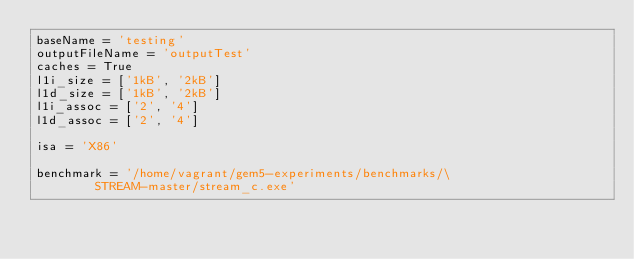<code> <loc_0><loc_0><loc_500><loc_500><_Python_>baseName = 'testing'
outputFileName = 'outputTest'
caches = True
l1i_size = ['1kB', '2kB']
l1d_size = ['1kB', '2kB']
l1i_assoc = ['2', '4']
l1d_assoc = ['2', '4']

isa = 'X86'

benchmark = '/home/vagrant/gem5-experiments/benchmarks/\
        STREAM-master/stream_c.exe'


</code> 